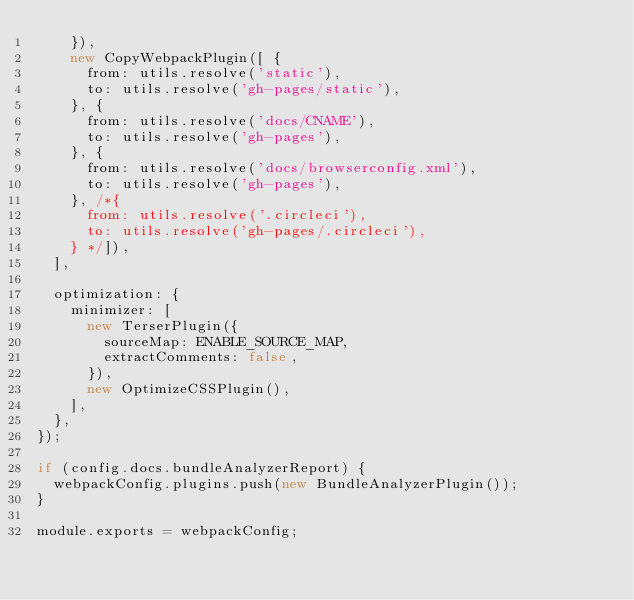<code> <loc_0><loc_0><loc_500><loc_500><_JavaScript_>    }),
    new CopyWebpackPlugin([ {
      from: utils.resolve('static'),
      to: utils.resolve('gh-pages/static'),
    }, {
      from: utils.resolve('docs/CNAME'),
      to: utils.resolve('gh-pages'),
    }, {
      from: utils.resolve('docs/browserconfig.xml'),
      to: utils.resolve('gh-pages'),
    }, /*{
      from: utils.resolve('.circleci'),
      to: utils.resolve('gh-pages/.circleci'),
    } */]),
  ],

  optimization: {
    minimizer: [
      new TerserPlugin({
        sourceMap: ENABLE_SOURCE_MAP,
        extractComments: false,
      }),
      new OptimizeCSSPlugin(),
    ],
  },
});

if (config.docs.bundleAnalyzerReport) {
  webpackConfig.plugins.push(new BundleAnalyzerPlugin());
}

module.exports = webpackConfig;
</code> 